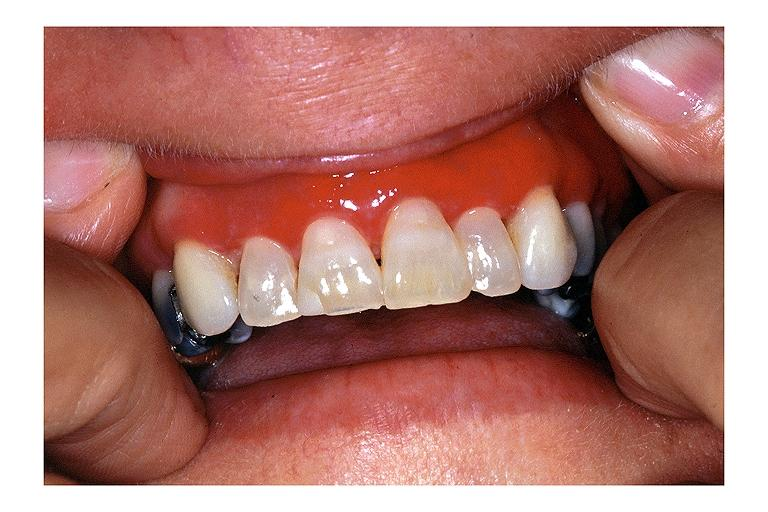what is present?
Answer the question using a single word or phrase. Oral 